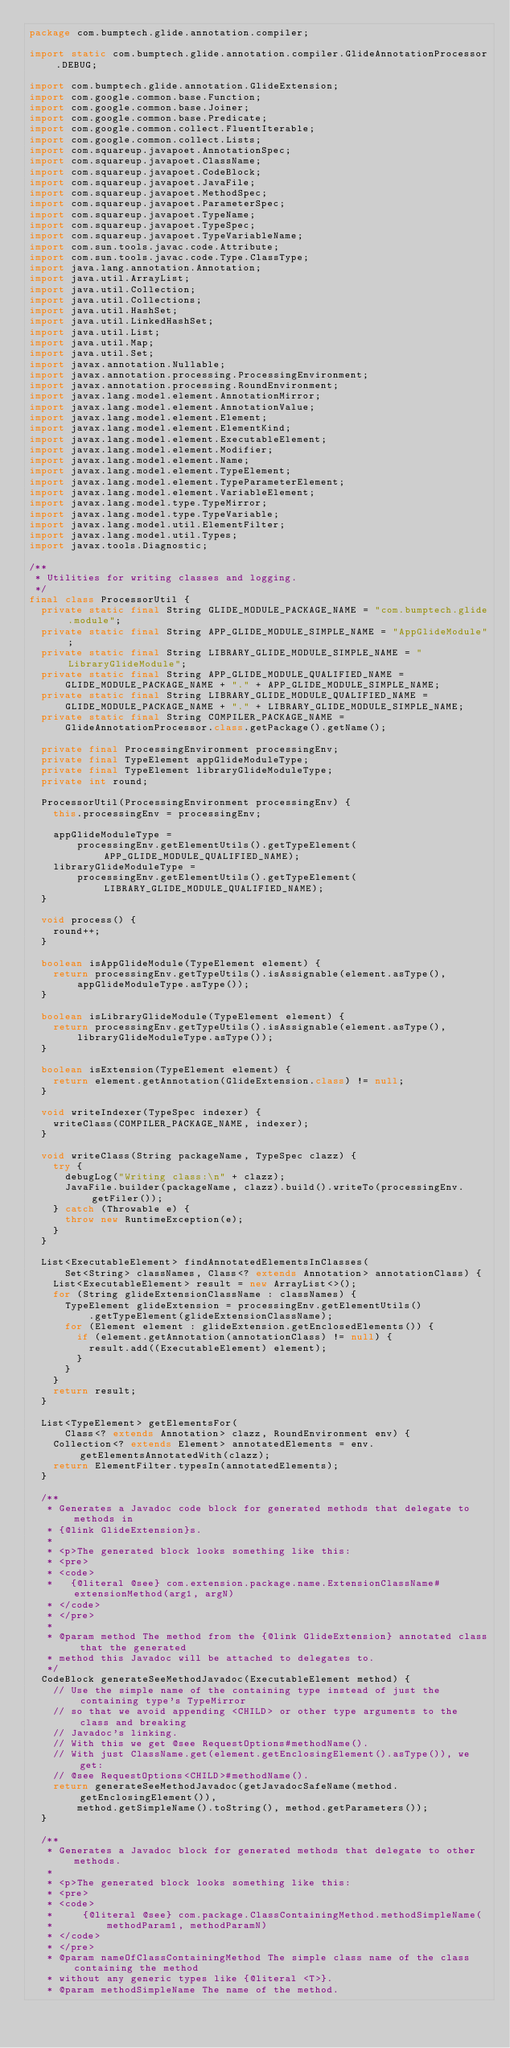Convert code to text. <code><loc_0><loc_0><loc_500><loc_500><_Java_>package com.bumptech.glide.annotation.compiler;

import static com.bumptech.glide.annotation.compiler.GlideAnnotationProcessor.DEBUG;

import com.bumptech.glide.annotation.GlideExtension;
import com.google.common.base.Function;
import com.google.common.base.Joiner;
import com.google.common.base.Predicate;
import com.google.common.collect.FluentIterable;
import com.google.common.collect.Lists;
import com.squareup.javapoet.AnnotationSpec;
import com.squareup.javapoet.ClassName;
import com.squareup.javapoet.CodeBlock;
import com.squareup.javapoet.JavaFile;
import com.squareup.javapoet.MethodSpec;
import com.squareup.javapoet.ParameterSpec;
import com.squareup.javapoet.TypeName;
import com.squareup.javapoet.TypeSpec;
import com.squareup.javapoet.TypeVariableName;
import com.sun.tools.javac.code.Attribute;
import com.sun.tools.javac.code.Type.ClassType;
import java.lang.annotation.Annotation;
import java.util.ArrayList;
import java.util.Collection;
import java.util.Collections;
import java.util.HashSet;
import java.util.LinkedHashSet;
import java.util.List;
import java.util.Map;
import java.util.Set;
import javax.annotation.Nullable;
import javax.annotation.processing.ProcessingEnvironment;
import javax.annotation.processing.RoundEnvironment;
import javax.lang.model.element.AnnotationMirror;
import javax.lang.model.element.AnnotationValue;
import javax.lang.model.element.Element;
import javax.lang.model.element.ElementKind;
import javax.lang.model.element.ExecutableElement;
import javax.lang.model.element.Modifier;
import javax.lang.model.element.Name;
import javax.lang.model.element.TypeElement;
import javax.lang.model.element.TypeParameterElement;
import javax.lang.model.element.VariableElement;
import javax.lang.model.type.TypeMirror;
import javax.lang.model.type.TypeVariable;
import javax.lang.model.util.ElementFilter;
import javax.lang.model.util.Types;
import javax.tools.Diagnostic;

/**
 * Utilities for writing classes and logging.
 */
final class ProcessorUtil {
  private static final String GLIDE_MODULE_PACKAGE_NAME = "com.bumptech.glide.module";
  private static final String APP_GLIDE_MODULE_SIMPLE_NAME = "AppGlideModule";
  private static final String LIBRARY_GLIDE_MODULE_SIMPLE_NAME = "LibraryGlideModule";
  private static final String APP_GLIDE_MODULE_QUALIFIED_NAME =
      GLIDE_MODULE_PACKAGE_NAME + "." + APP_GLIDE_MODULE_SIMPLE_NAME;
  private static final String LIBRARY_GLIDE_MODULE_QUALIFIED_NAME =
      GLIDE_MODULE_PACKAGE_NAME + "." + LIBRARY_GLIDE_MODULE_SIMPLE_NAME;
  private static final String COMPILER_PACKAGE_NAME =
      GlideAnnotationProcessor.class.getPackage().getName();

  private final ProcessingEnvironment processingEnv;
  private final TypeElement appGlideModuleType;
  private final TypeElement libraryGlideModuleType;
  private int round;

  ProcessorUtil(ProcessingEnvironment processingEnv) {
    this.processingEnv = processingEnv;

    appGlideModuleType =
        processingEnv.getElementUtils().getTypeElement(APP_GLIDE_MODULE_QUALIFIED_NAME);
    libraryGlideModuleType =
        processingEnv.getElementUtils().getTypeElement(LIBRARY_GLIDE_MODULE_QUALIFIED_NAME);
  }

  void process() {
    round++;
  }

  boolean isAppGlideModule(TypeElement element) {
    return processingEnv.getTypeUtils().isAssignable(element.asType(),
        appGlideModuleType.asType());
  }

  boolean isLibraryGlideModule(TypeElement element) {
    return processingEnv.getTypeUtils().isAssignable(element.asType(),
        libraryGlideModuleType.asType());
  }

  boolean isExtension(TypeElement element) {
    return element.getAnnotation(GlideExtension.class) != null;
  }

  void writeIndexer(TypeSpec indexer) {
    writeClass(COMPILER_PACKAGE_NAME, indexer);
  }

  void writeClass(String packageName, TypeSpec clazz) {
    try {
      debugLog("Writing class:\n" + clazz);
      JavaFile.builder(packageName, clazz).build().writeTo(processingEnv.getFiler());
    } catch (Throwable e) {
      throw new RuntimeException(e);
    }
  }

  List<ExecutableElement> findAnnotatedElementsInClasses(
      Set<String> classNames, Class<? extends Annotation> annotationClass) {
    List<ExecutableElement> result = new ArrayList<>();
    for (String glideExtensionClassName : classNames) {
      TypeElement glideExtension = processingEnv.getElementUtils()
          .getTypeElement(glideExtensionClassName);
      for (Element element : glideExtension.getEnclosedElements()) {
        if (element.getAnnotation(annotationClass) != null) {
          result.add((ExecutableElement) element);
        }
      }
    }
    return result;
  }

  List<TypeElement> getElementsFor(
      Class<? extends Annotation> clazz, RoundEnvironment env) {
    Collection<? extends Element> annotatedElements = env.getElementsAnnotatedWith(clazz);
    return ElementFilter.typesIn(annotatedElements);
  }

  /**
   * Generates a Javadoc code block for generated methods that delegate to methods in
   * {@link GlideExtension}s.
   *
   * <p>The generated block looks something like this:
   * <pre>
   * <code>
   *   {@literal @see} com.extension.package.name.ExtensionClassName#extensionMethod(arg1, argN)
   * </code>
   * </pre>
   *
   * @param method The method from the {@link GlideExtension} annotated class that the generated
   * method this Javadoc will be attached to delegates to.
   */
  CodeBlock generateSeeMethodJavadoc(ExecutableElement method) {
    // Use the simple name of the containing type instead of just the containing type's TypeMirror
    // so that we avoid appending <CHILD> or other type arguments to the class and breaking
    // Javadoc's linking.
    // With this we get @see RequestOptions#methodName().
    // With just ClassName.get(element.getEnclosingElement().asType()), we get:
    // @see RequestOptions<CHILD>#methodName().
    return generateSeeMethodJavadoc(getJavadocSafeName(method.getEnclosingElement()),
        method.getSimpleName().toString(), method.getParameters());
  }

  /**
   * Generates a Javadoc block for generated methods that delegate to other methods.
   *
   * <p>The generated block looks something like this:
   * <pre>
   * <code>
   *     {@literal @see} com.package.ClassContainingMethod.methodSimpleName(
   *         methodParam1, methodParamN)
   * </code>
   * </pre>
   * @param nameOfClassContainingMethod The simple class name of the class containing the method
   * without any generic types like {@literal <T>}.
   * @param methodSimpleName The name of the method.</code> 